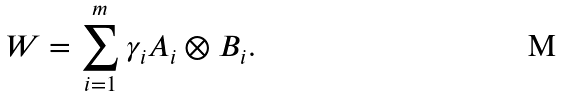Convert formula to latex. <formula><loc_0><loc_0><loc_500><loc_500>W = \sum _ { i = 1 } ^ { m } \gamma _ { i } A _ { i } \otimes B _ { i } .</formula> 